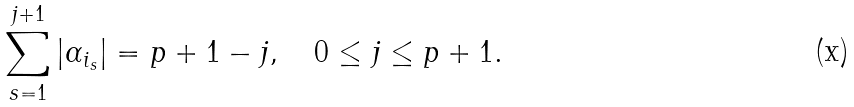<formula> <loc_0><loc_0><loc_500><loc_500>\sum _ { s = 1 } ^ { j + 1 } | \alpha _ { i _ { s } } | = p + 1 - j , \quad 0 \leq j \leq p + 1 .</formula> 